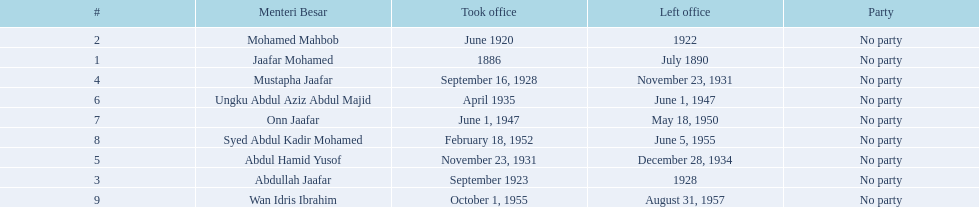Who were the menteri besar of johor? Jaafar Mohamed, Mohamed Mahbob, Abdullah Jaafar, Mustapha Jaafar, Abdul Hamid Yusof, Ungku Abdul Aziz Abdul Majid, Onn Jaafar, Syed Abdul Kadir Mohamed, Wan Idris Ibrahim. Who served the longest? Ungku Abdul Aziz Abdul Majid. 